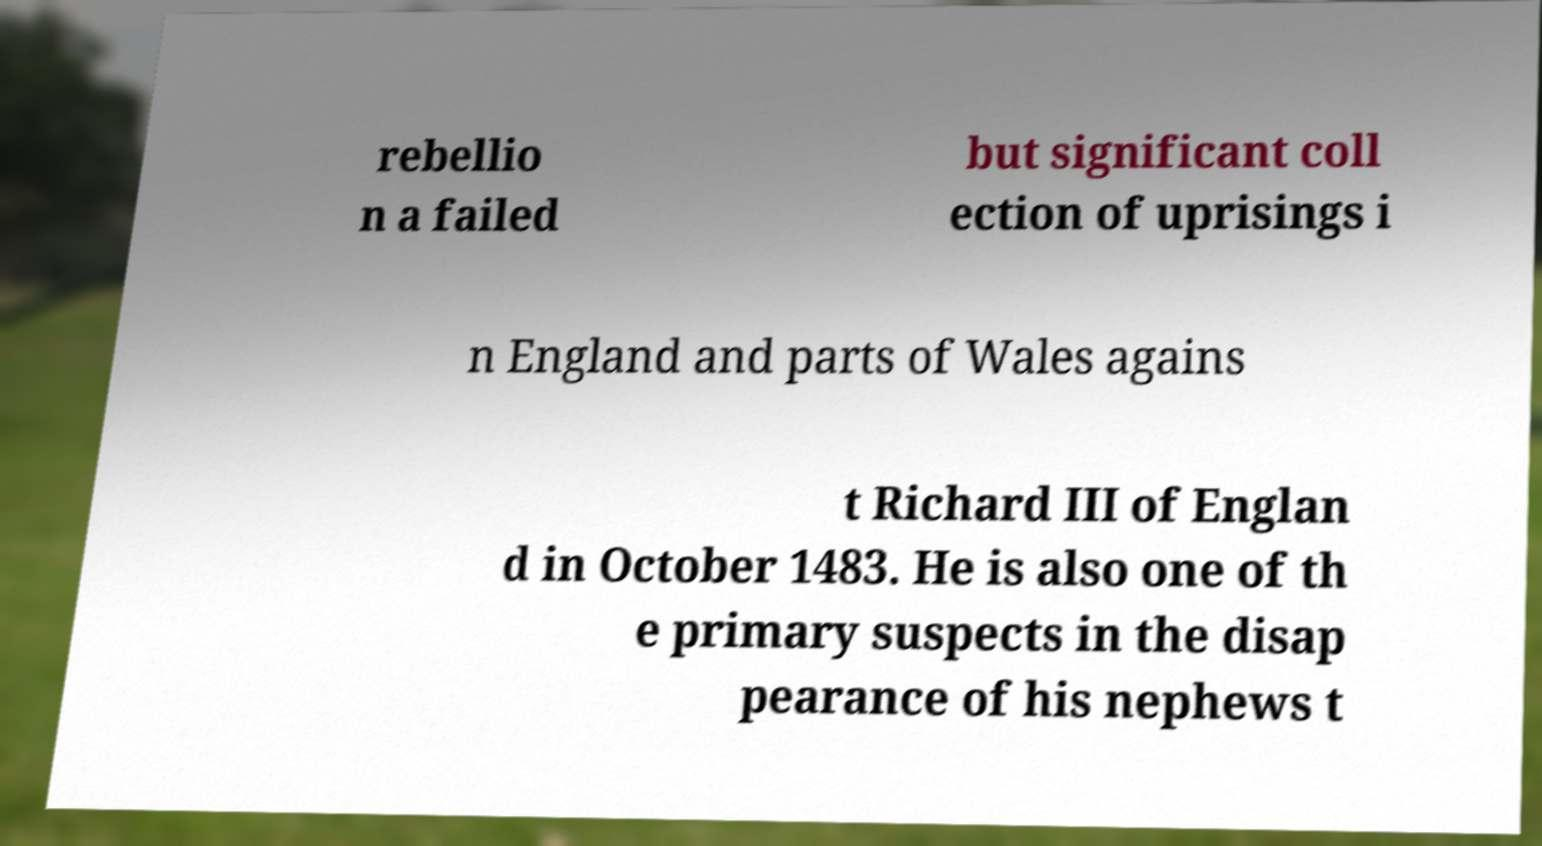For documentation purposes, I need the text within this image transcribed. Could you provide that? rebellio n a failed but significant coll ection of uprisings i n England and parts of Wales agains t Richard III of Englan d in October 1483. He is also one of th e primary suspects in the disap pearance of his nephews t 